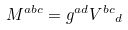Convert formula to latex. <formula><loc_0><loc_0><loc_500><loc_500>M ^ { a b c } = g ^ { a d } { V ^ { b c } } _ { d }</formula> 